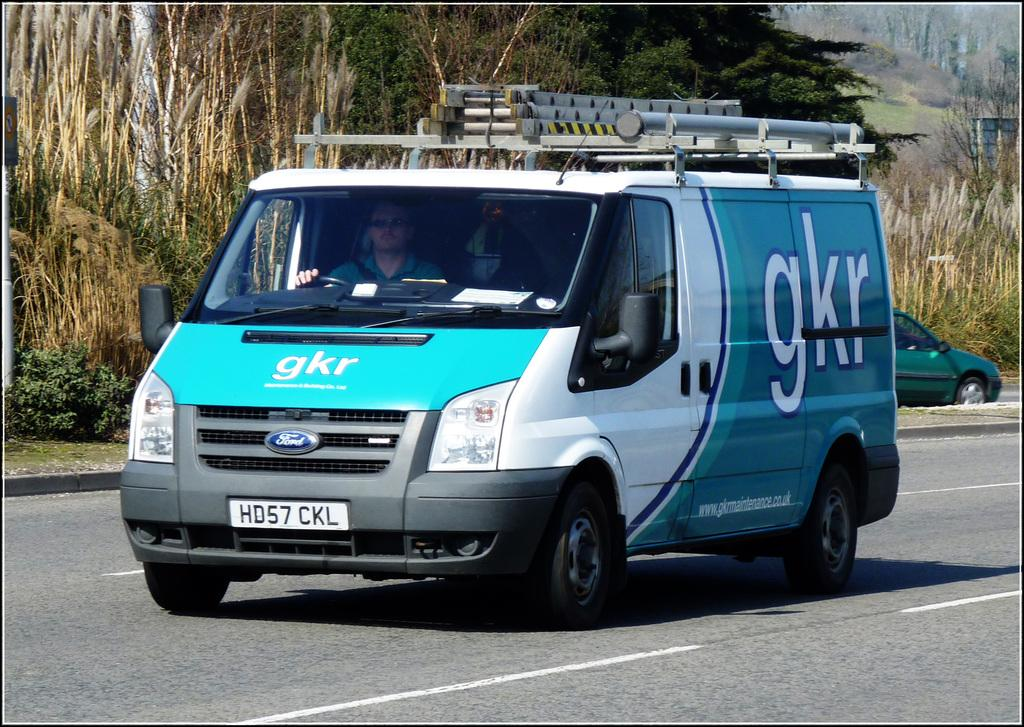Provide a one-sentence caption for the provided image. A gkr van is driving down the road. 